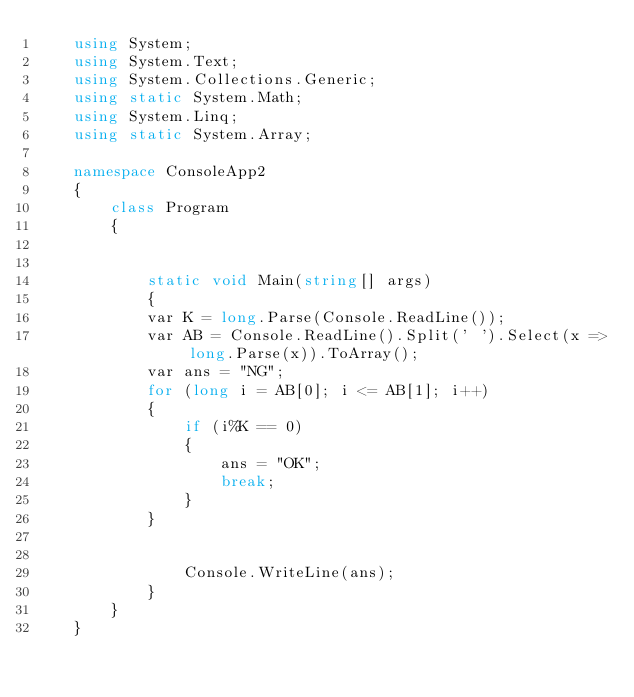Convert code to text. <code><loc_0><loc_0><loc_500><loc_500><_C#_>    using System;
    using System.Text;
    using System.Collections.Generic;
    using static System.Math;
    using System.Linq;
    using static System.Array;

    namespace ConsoleApp2
    {
        class Program
        {


            static void Main(string[] args)
            {
            var K = long.Parse(Console.ReadLine());
            var AB = Console.ReadLine().Split(' ').Select(x => long.Parse(x)).ToArray();
            var ans = "NG";
            for (long i = AB[0]; i <= AB[1]; i++)
            {
                if (i%K == 0)
                {
                    ans = "OK";
                    break;
                }
            }


                Console.WriteLine(ans);
            }
        }
    }
</code> 